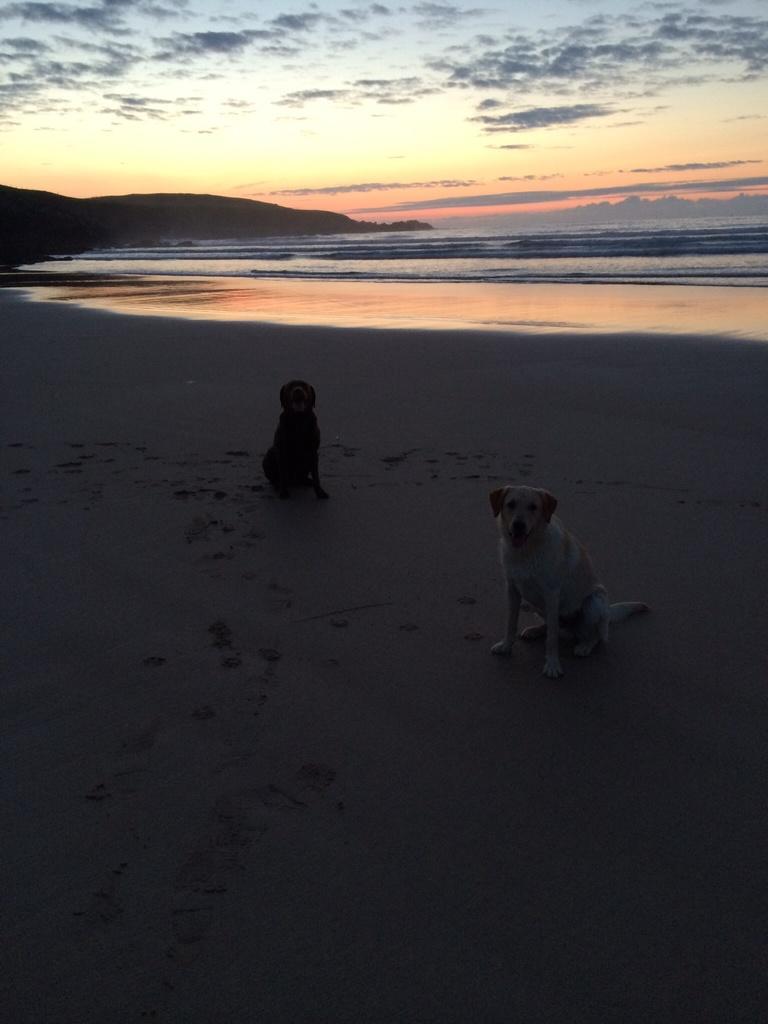How would you summarize this image in a sentence or two? In the center of the image we can see two dogs. In the background, we can see the sky, clouds, water and a hill. 